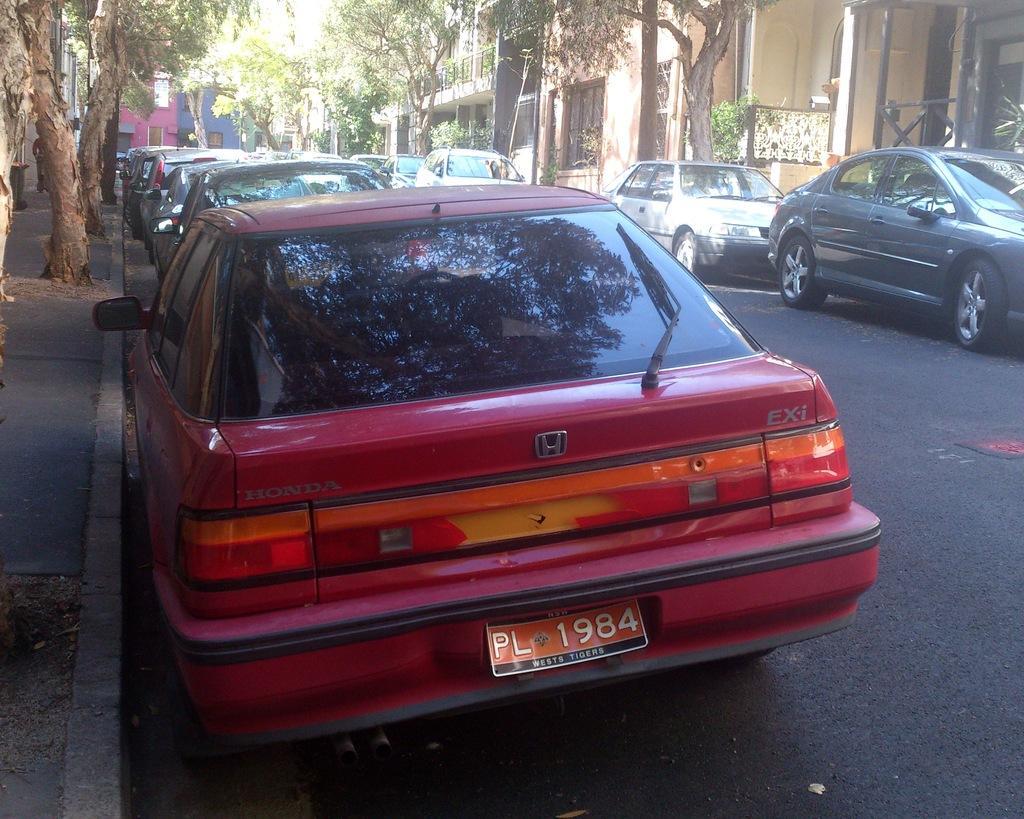How would you summarize this image in a sentence or two? In the center of the image there are cars on the road. There are trees. In the background of the image there are buildings. 